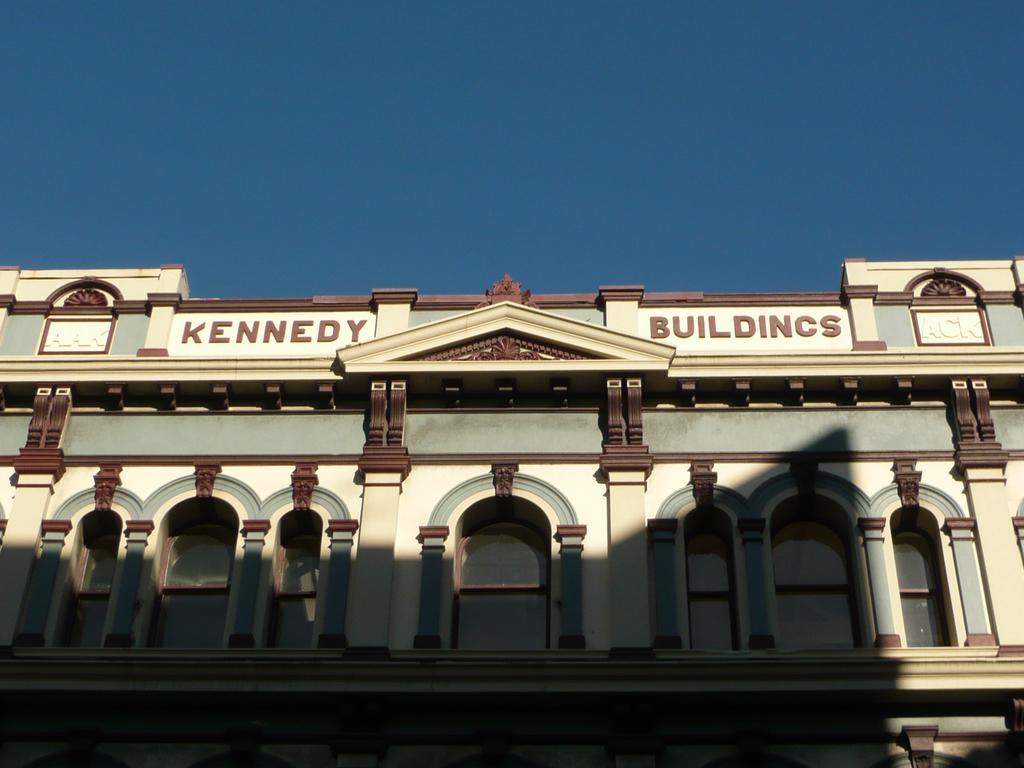In one or two sentences, can you explain what this image depicts? In this image, we can see a building with some text. We can also see the sky. 